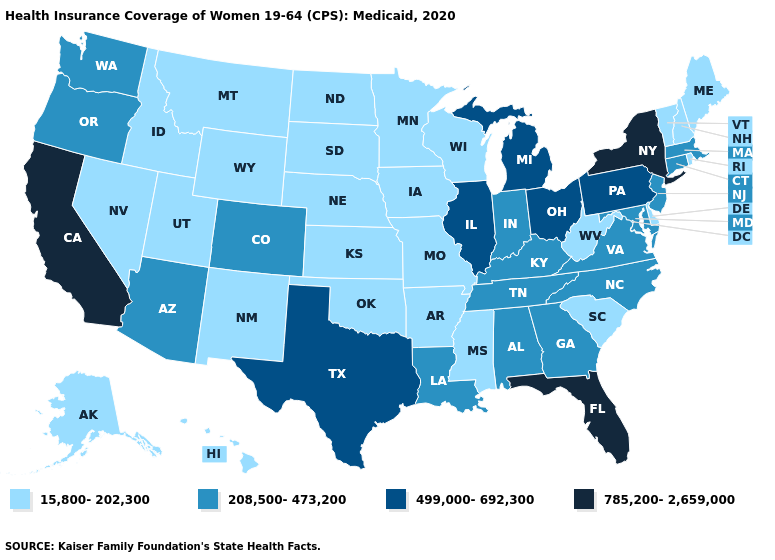Does California have the highest value in the West?
Keep it brief. Yes. What is the value of Kansas?
Be succinct. 15,800-202,300. Among the states that border Wyoming , which have the lowest value?
Short answer required. Idaho, Montana, Nebraska, South Dakota, Utah. Name the states that have a value in the range 15,800-202,300?
Short answer required. Alaska, Arkansas, Delaware, Hawaii, Idaho, Iowa, Kansas, Maine, Minnesota, Mississippi, Missouri, Montana, Nebraska, Nevada, New Hampshire, New Mexico, North Dakota, Oklahoma, Rhode Island, South Carolina, South Dakota, Utah, Vermont, West Virginia, Wisconsin, Wyoming. Does Ohio have the highest value in the MidWest?
Short answer required. Yes. Does Maine have the lowest value in the Northeast?
Give a very brief answer. Yes. Does Illinois have the lowest value in the USA?
Be succinct. No. Name the states that have a value in the range 208,500-473,200?
Short answer required. Alabama, Arizona, Colorado, Connecticut, Georgia, Indiana, Kentucky, Louisiana, Maryland, Massachusetts, New Jersey, North Carolina, Oregon, Tennessee, Virginia, Washington. What is the value of Illinois?
Give a very brief answer. 499,000-692,300. Does Rhode Island have the same value as Indiana?
Be succinct. No. What is the value of Oregon?
Keep it brief. 208,500-473,200. Which states hav the highest value in the Northeast?
Keep it brief. New York. What is the highest value in the South ?
Be succinct. 785,200-2,659,000. Name the states that have a value in the range 15,800-202,300?
Short answer required. Alaska, Arkansas, Delaware, Hawaii, Idaho, Iowa, Kansas, Maine, Minnesota, Mississippi, Missouri, Montana, Nebraska, Nevada, New Hampshire, New Mexico, North Dakota, Oklahoma, Rhode Island, South Carolina, South Dakota, Utah, Vermont, West Virginia, Wisconsin, Wyoming. Among the states that border Arkansas , does Texas have the lowest value?
Short answer required. No. 